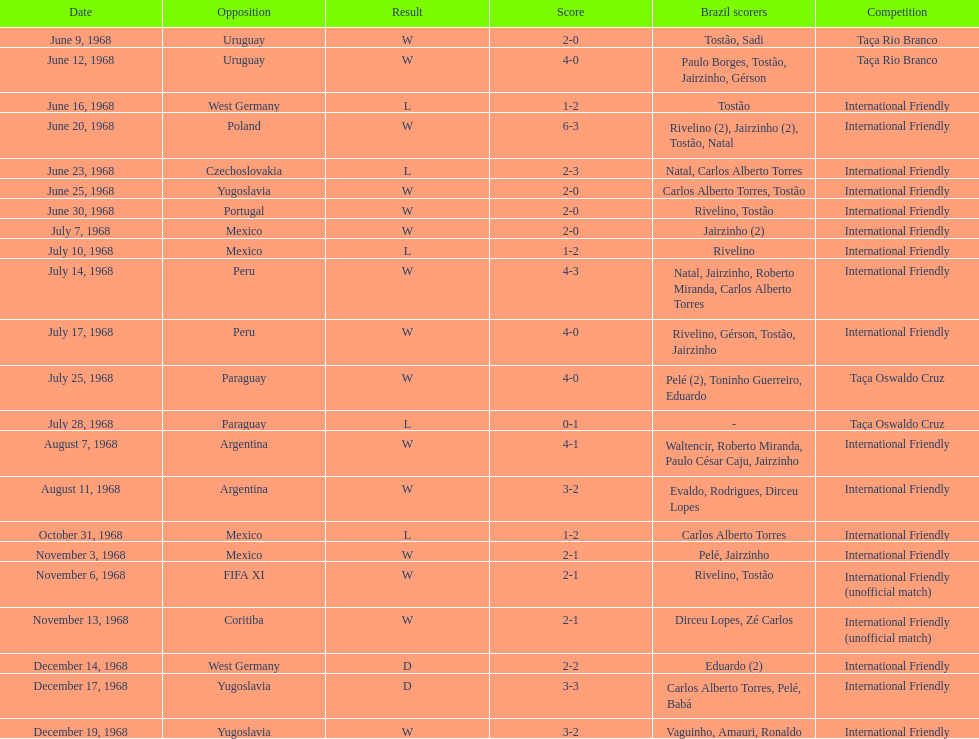What is the number of countries they have played? 11. 